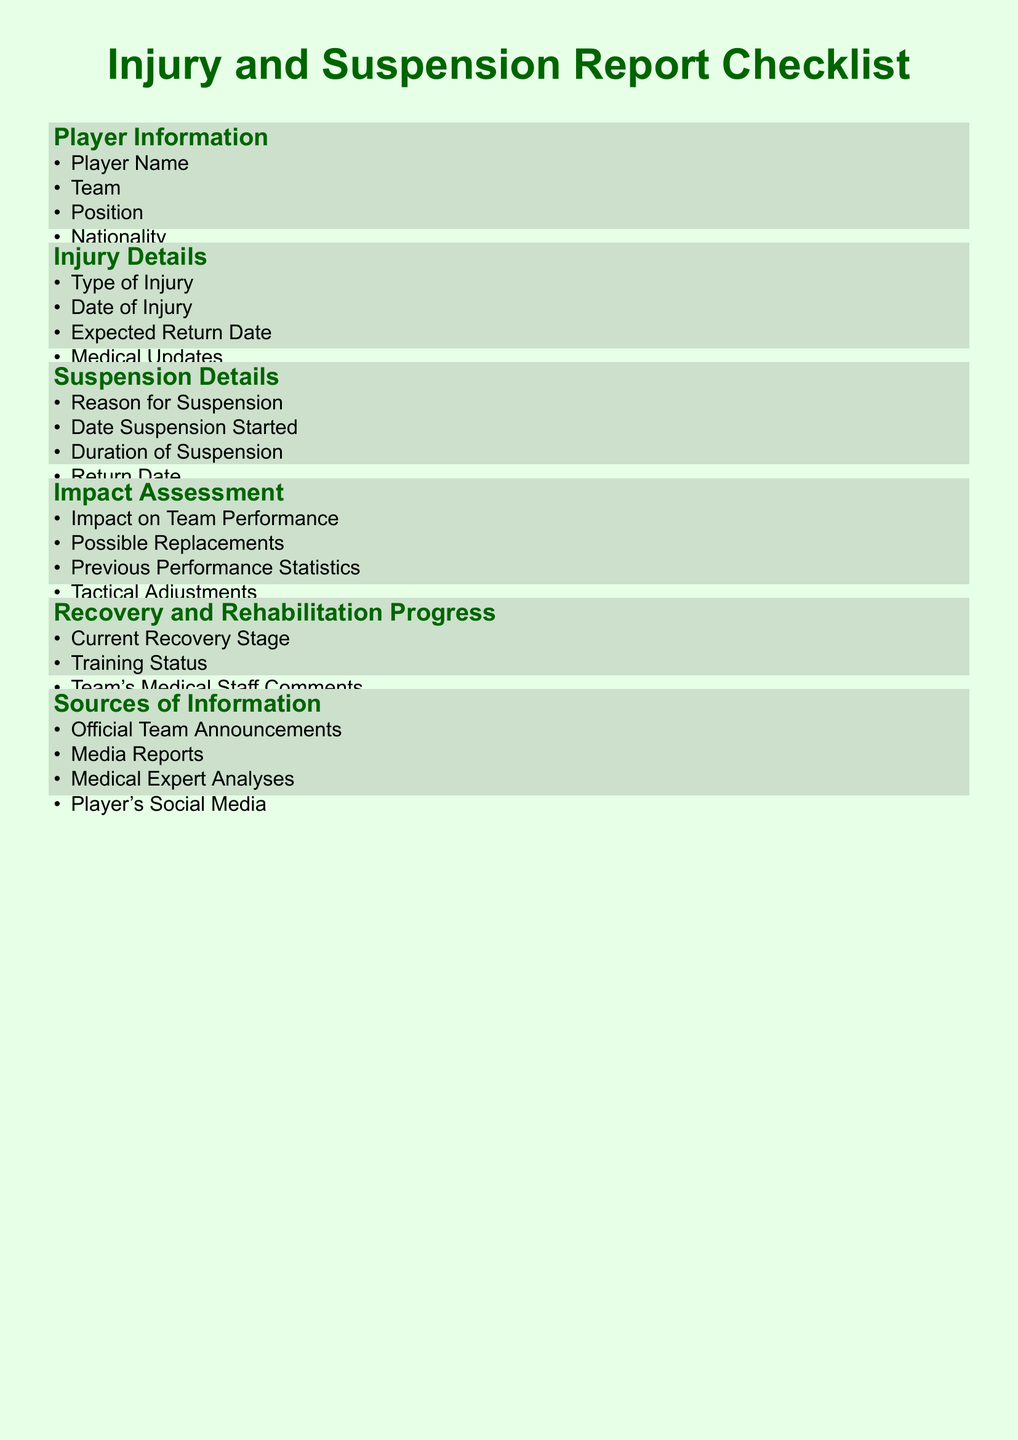What is the document's title? The title of the document is presented prominently at the beginning, indicating its focus on injuries and suspensions.
Answer: Injury and Suspension Report Checklist What details are required for player information? The checklist outlines the specific categories of data needed regarding player information.
Answer: Player Name, Team, Position, Nationality What type of updates are included in injury details? This section specifies the nature of updates on a player's injury condition that need to be tracked.
Answer: Medical Updates What is assessed to understand the impact on team performance? The document includes specific areas that relate to the evaluation of how player absences affect the team.
Answer: Impact on Team Performance, Possible Replacements, Previous Performance Statistics, Tactical Adjustments What is a source of information provided in the document? The checklist categorizes various origins of data that can support the assessment of injuries and suspensions.
Answer: Official Team Announcements, Media Reports, Medical Expert Analyses, Player's Social Media What does the recovery progress section assess? This section focuses on the player's rehabilitation and overall recovery state after an injury or suspension.
Answer: Current Recovery Stage, Training Status, Team's Medical Staff Comments What type of injury details are included in the report? The report explicitly mentions the different aspects of injury details that need to be documented.
Answer: Type of Injury, Date of Injury, Expected Return Date How would you categorize the document? This refers to the genre or classification that fits the nature of the content presented in the document.
Answer: Checklist 